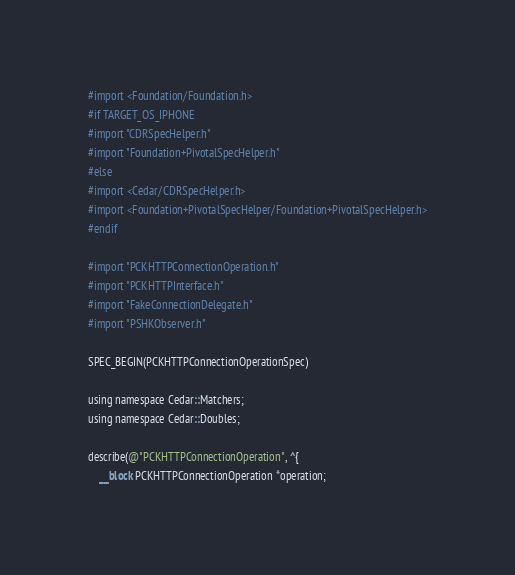<code> <loc_0><loc_0><loc_500><loc_500><_ObjectiveC_>#import <Foundation/Foundation.h>
#if TARGET_OS_IPHONE
#import "CDRSpecHelper.h"
#import "Foundation+PivotalSpecHelper.h"
#else
#import <Cedar/CDRSpecHelper.h>
#import <Foundation+PivotalSpecHelper/Foundation+PivotalSpecHelper.h>
#endif

#import "PCKHTTPConnectionOperation.h"
#import "PCKHTTPInterface.h"
#import "FakeConnectionDelegate.h"
#import "PSHKObserver.h"

SPEC_BEGIN(PCKHTTPConnectionOperationSpec)

using namespace Cedar::Matchers;
using namespace Cedar::Doubles;

describe(@"PCKHTTPConnectionOperation", ^{
    __block PCKHTTPConnectionOperation *operation;</code> 